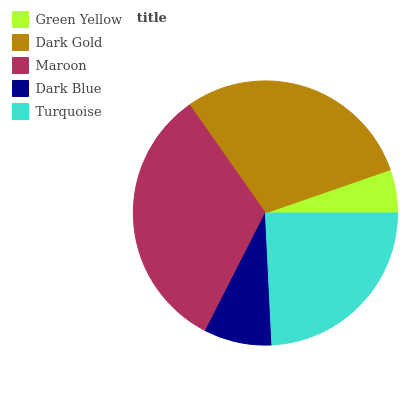Is Green Yellow the minimum?
Answer yes or no. Yes. Is Maroon the maximum?
Answer yes or no. Yes. Is Dark Gold the minimum?
Answer yes or no. No. Is Dark Gold the maximum?
Answer yes or no. No. Is Dark Gold greater than Green Yellow?
Answer yes or no. Yes. Is Green Yellow less than Dark Gold?
Answer yes or no. Yes. Is Green Yellow greater than Dark Gold?
Answer yes or no. No. Is Dark Gold less than Green Yellow?
Answer yes or no. No. Is Turquoise the high median?
Answer yes or no. Yes. Is Turquoise the low median?
Answer yes or no. Yes. Is Green Yellow the high median?
Answer yes or no. No. Is Dark Blue the low median?
Answer yes or no. No. 